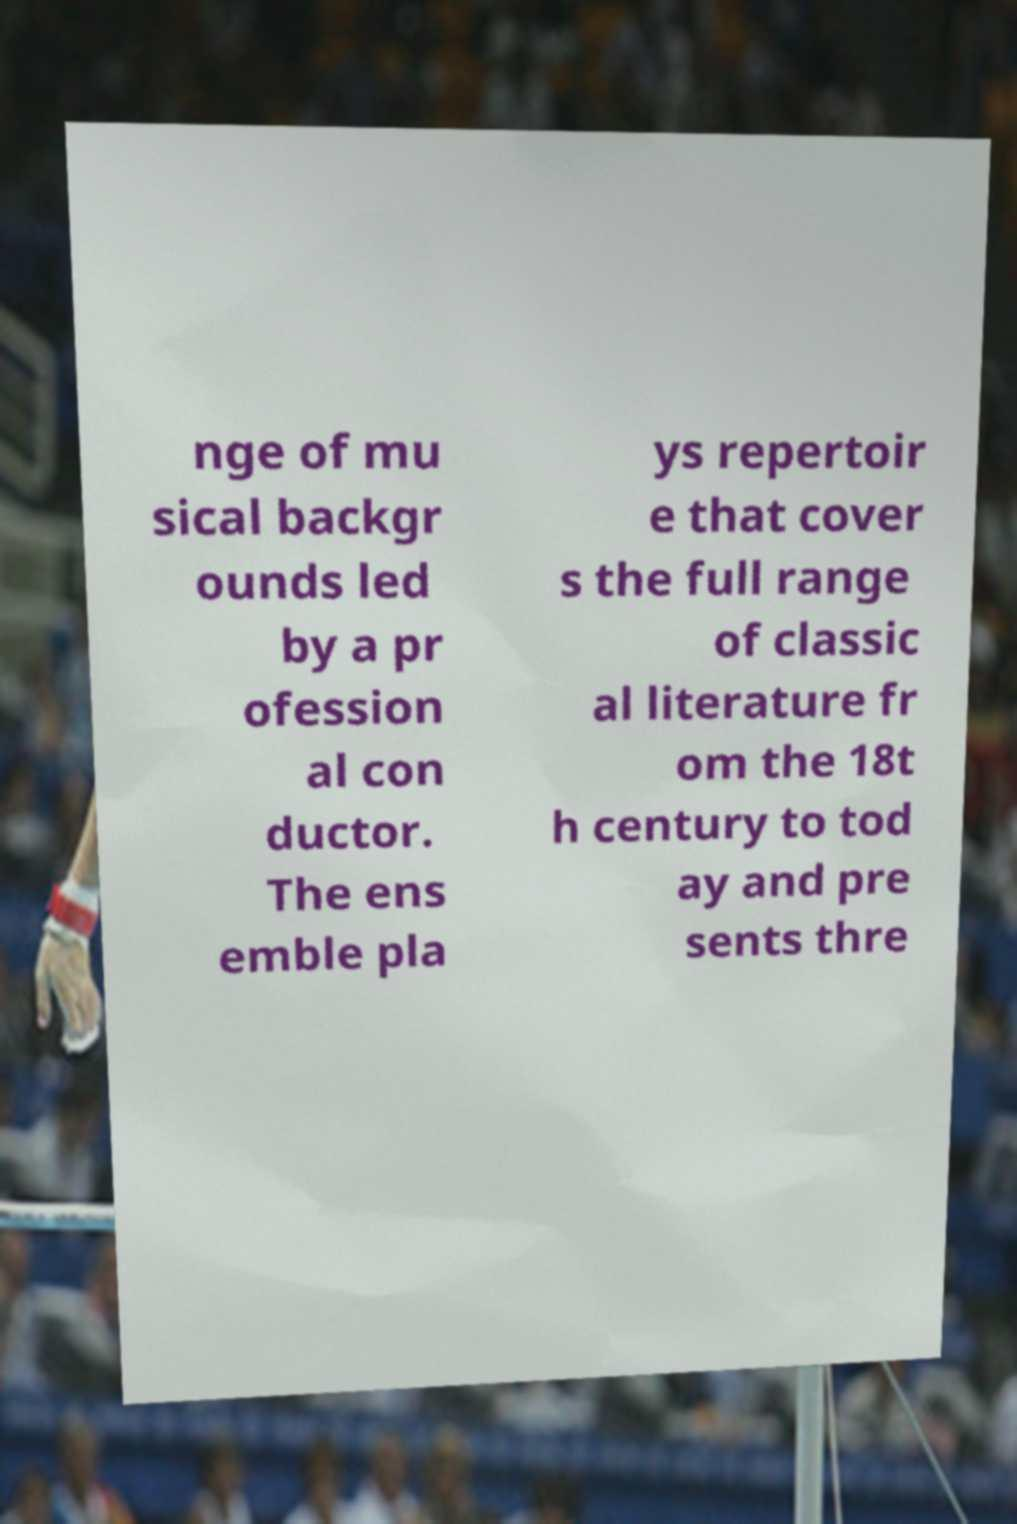Please identify and transcribe the text found in this image. nge of mu sical backgr ounds led by a pr ofession al con ductor. The ens emble pla ys repertoir e that cover s the full range of classic al literature fr om the 18t h century to tod ay and pre sents thre 